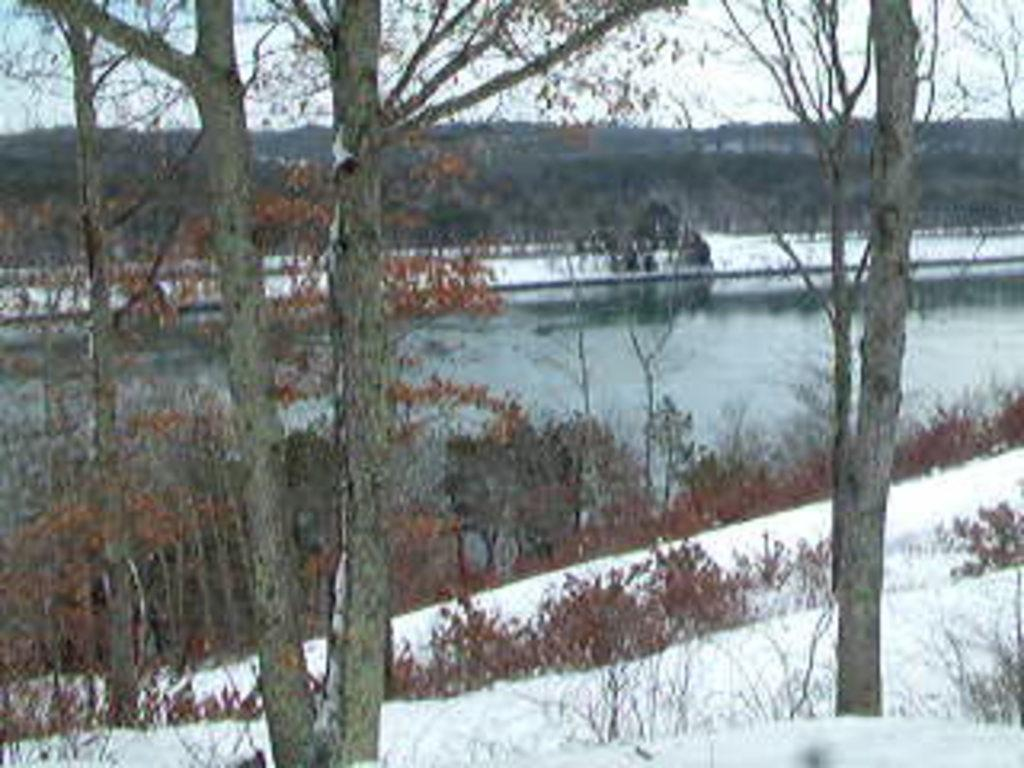What is the primary element present in the image? There is water in the image. What type of vegetation can be seen in the image? There are trees and plants in the image. What is the weather like in the image? There is snow visible in the image, indicating a cold or wintery environment. What can be seen in the background of the image? The sky is visible in the background of the image. Where is the quiet meeting taking place in the image? There is no meeting or quiet location mentioned in the image; it primarily features water, trees, plants, snow, and the sky. 